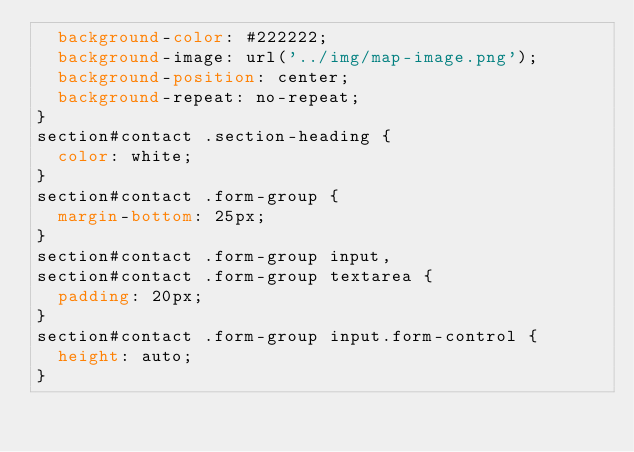<code> <loc_0><loc_0><loc_500><loc_500><_CSS_>  background-color: #222222;
  background-image: url('../img/map-image.png');
  background-position: center;
  background-repeat: no-repeat;
}
section#contact .section-heading {
  color: white;
}
section#contact .form-group {
  margin-bottom: 25px;
}
section#contact .form-group input,
section#contact .form-group textarea {
  padding: 20px;
}
section#contact .form-group input.form-control {
  height: auto;
}</code> 